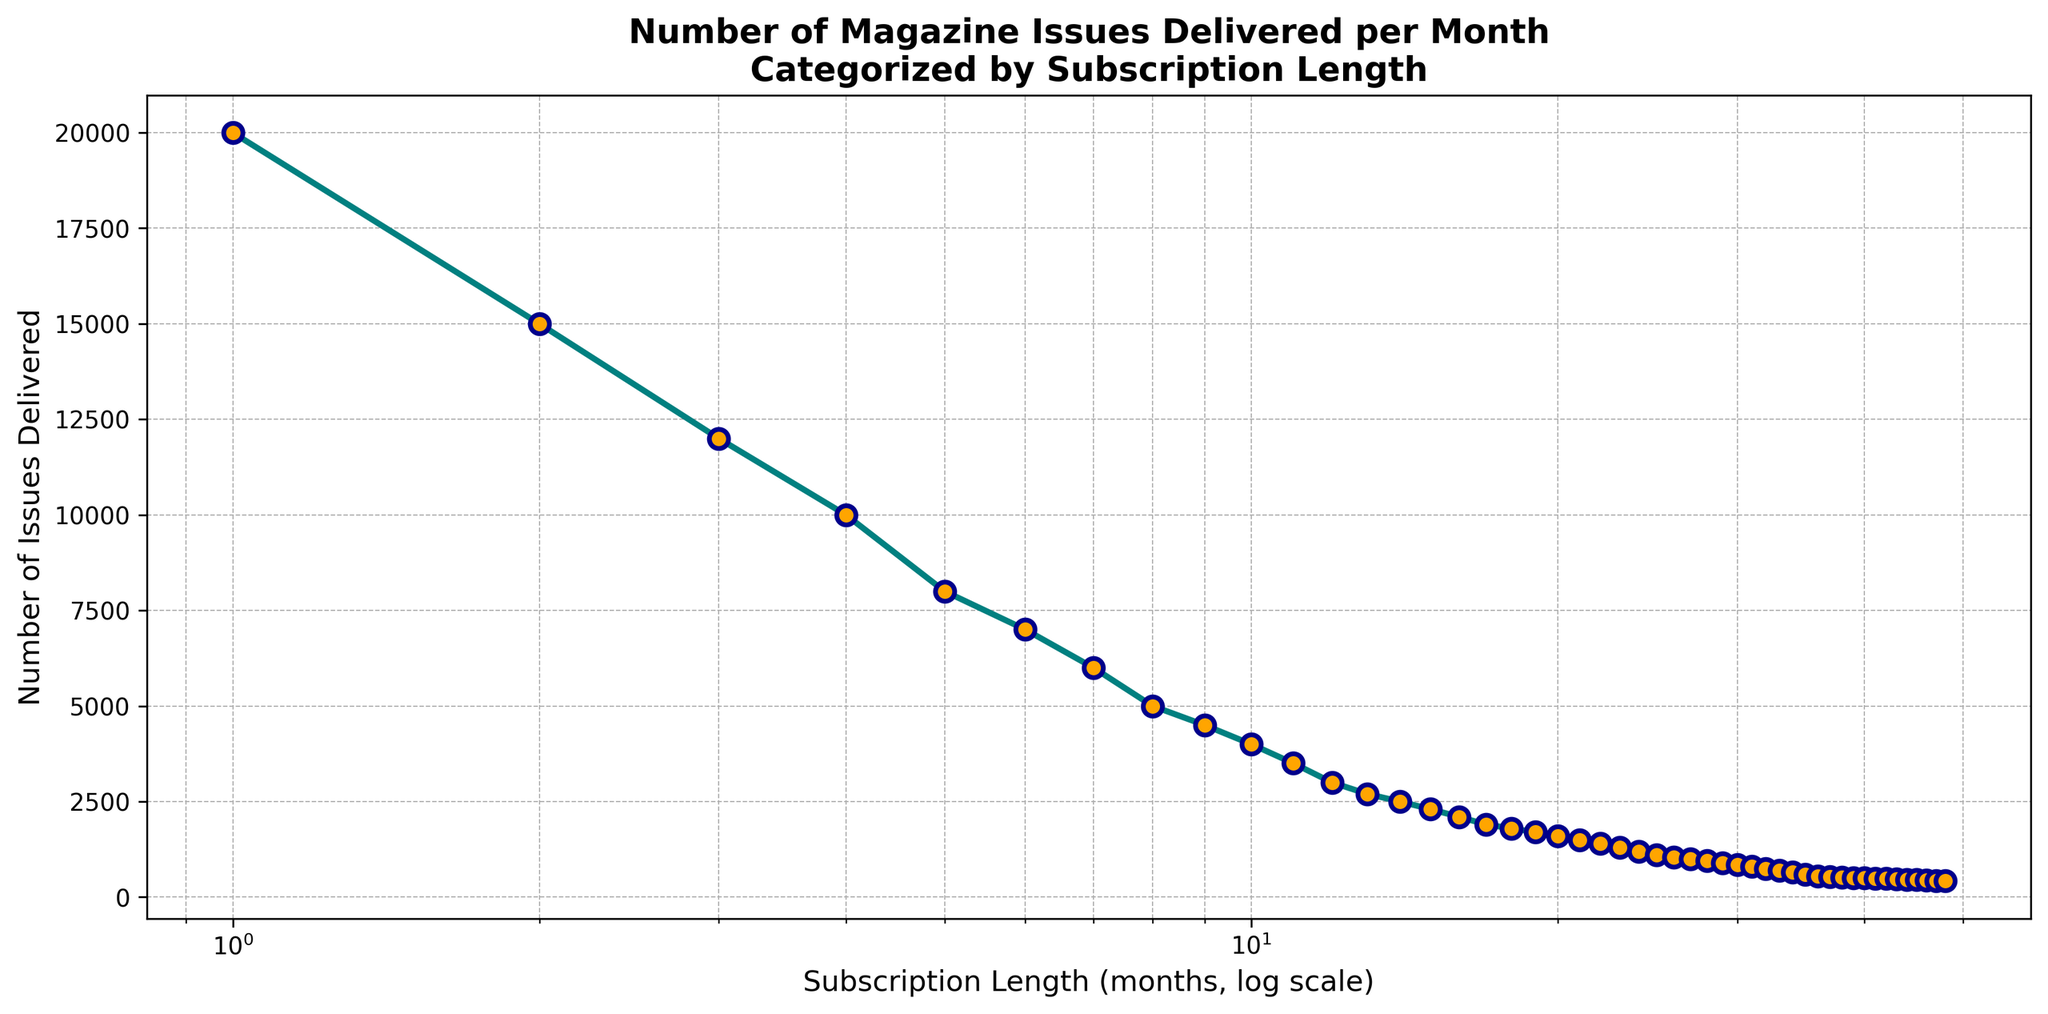what is the number of issues delivered in the first month compared to the twelfth month? To find the number of issues delivered in the first and twelfth months, refer to the y-values at the x-values of 1 and 12 on the plot. The plot shows that 20000 issues were delivered in the first month and 3000 in the twelfth month.
Answer: 20000 and 3000 How does the number of issues delivered change between the 5th month and the 10th month? Refer to the y-values at the x-values of 5 and 10 on the plot. The number of issues delivered in the 5th month is 8000, and in the 10th month, it is 4000. Subtract to find the difference: 8000 - 4000 = 4000.
Answer: Decreases by 4000 How many issues are delivered in the 24th month? Look at the y-value for an x-value of 24 on the plot. The point for the 24th month shows 1200 issues.
Answer: 1200 What is the average number of issues delivered from the first to the fourth month? The number of issues delivered in the first to the fourth months are 20000, 15000, 12000, and 10000 respectively. Calculate the average: (20000 + 15000 + 12000 + 10000) / 4 = 14250.
Answer: 14250 How does the trend in the number of issues delivered change as the subscription length increases? Observe the overall trend on the plot. The number of issues delivered generally decreases as the subscription length increases. The curve slopes downward.
Answer: Decreasing trend Which subscription length sees the largest number of issues delivered per month? The highest point on the plot corresponds to the first month, at an x-value of 1, with 20000 issues delivered.
Answer: First month (1 month) Is the number of issues delivered in the 30th month more or less than half the number of issues delivered in the 10th month? The number of issues in the 10th month is 4000. Half of this is 2000. Compare with the y-value at an x-value of 30 which is 850. 850 is less than 2000.
Answer: Less What is the number of issues delivered in the months with subscription lengths of 36 and 48 months? Refer to the y-values at x-values of 36 and 48. The plot shows 550 issues in the 36th month and 420 issues in the 48th month.
Answer: 550 and 420 Does the number of issues delivered between the 15th and the 20th month follow a linear decline? Examine the plot segment between x-values of 15 and 20. The decline appears more gradual and consistent rather than linear, with the points getting closer together.
Answer: No, it doesn't follow a linear decline 